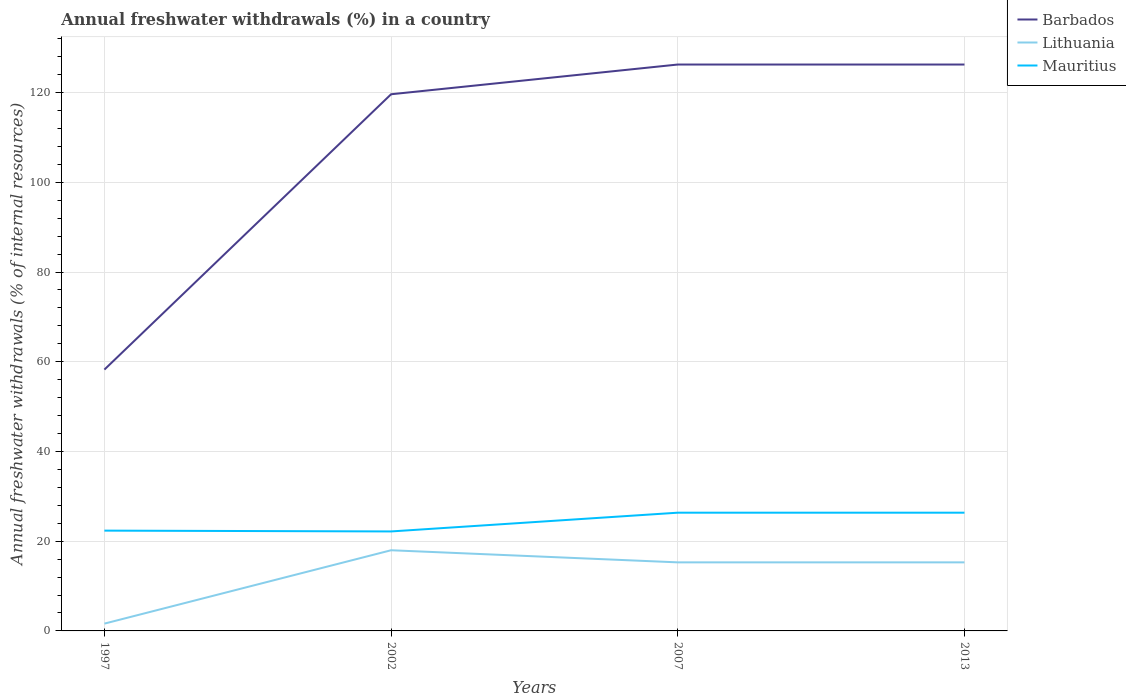How many different coloured lines are there?
Keep it short and to the point. 3. Is the number of lines equal to the number of legend labels?
Your response must be concise. Yes. Across all years, what is the maximum percentage of annual freshwater withdrawals in Lithuania?
Offer a very short reply. 1.63. What is the total percentage of annual freshwater withdrawals in Lithuania in the graph?
Your response must be concise. -13.66. What is the difference between the highest and the second highest percentage of annual freshwater withdrawals in Mauritius?
Your answer should be very brief. 4.18. Are the values on the major ticks of Y-axis written in scientific E-notation?
Your response must be concise. No. Does the graph contain any zero values?
Give a very brief answer. No. Does the graph contain grids?
Your response must be concise. Yes. How are the legend labels stacked?
Your response must be concise. Vertical. What is the title of the graph?
Your response must be concise. Annual freshwater withdrawals (%) in a country. Does "Qatar" appear as one of the legend labels in the graph?
Your response must be concise. No. What is the label or title of the Y-axis?
Ensure brevity in your answer.  Annual freshwater withdrawals (% of internal resources). What is the Annual freshwater withdrawals (% of internal resources) of Barbados in 1997?
Your response must be concise. 58.25. What is the Annual freshwater withdrawals (% of internal resources) of Lithuania in 1997?
Provide a succinct answer. 1.63. What is the Annual freshwater withdrawals (% of internal resources) of Mauritius in 1997?
Your answer should be compact. 22.36. What is the Annual freshwater withdrawals (% of internal resources) in Barbados in 2002?
Offer a very short reply. 119.62. What is the Annual freshwater withdrawals (% of internal resources) in Lithuania in 2002?
Ensure brevity in your answer.  17.98. What is the Annual freshwater withdrawals (% of internal resources) of Mauritius in 2002?
Offer a very short reply. 22.17. What is the Annual freshwater withdrawals (% of internal resources) of Barbados in 2007?
Ensure brevity in your answer.  126.25. What is the Annual freshwater withdrawals (% of internal resources) of Lithuania in 2007?
Offer a very short reply. 15.28. What is the Annual freshwater withdrawals (% of internal resources) in Mauritius in 2007?
Your answer should be very brief. 26.35. What is the Annual freshwater withdrawals (% of internal resources) of Barbados in 2013?
Your response must be concise. 126.25. What is the Annual freshwater withdrawals (% of internal resources) in Lithuania in 2013?
Keep it short and to the point. 15.28. What is the Annual freshwater withdrawals (% of internal resources) in Mauritius in 2013?
Offer a terse response. 26.35. Across all years, what is the maximum Annual freshwater withdrawals (% of internal resources) in Barbados?
Give a very brief answer. 126.25. Across all years, what is the maximum Annual freshwater withdrawals (% of internal resources) in Lithuania?
Provide a short and direct response. 17.98. Across all years, what is the maximum Annual freshwater withdrawals (% of internal resources) of Mauritius?
Your answer should be very brief. 26.35. Across all years, what is the minimum Annual freshwater withdrawals (% of internal resources) of Barbados?
Provide a short and direct response. 58.25. Across all years, what is the minimum Annual freshwater withdrawals (% of internal resources) in Lithuania?
Your answer should be very brief. 1.63. Across all years, what is the minimum Annual freshwater withdrawals (% of internal resources) of Mauritius?
Provide a succinct answer. 22.17. What is the total Annual freshwater withdrawals (% of internal resources) of Barbados in the graph?
Provide a succinct answer. 430.38. What is the total Annual freshwater withdrawals (% of internal resources) of Lithuania in the graph?
Ensure brevity in your answer.  50.17. What is the total Annual freshwater withdrawals (% of internal resources) in Mauritius in the graph?
Offer a very short reply. 97.24. What is the difference between the Annual freshwater withdrawals (% of internal resources) of Barbados in 1997 and that in 2002?
Give a very brief answer. -61.38. What is the difference between the Annual freshwater withdrawals (% of internal resources) of Lithuania in 1997 and that in 2002?
Offer a very short reply. -16.36. What is the difference between the Annual freshwater withdrawals (% of internal resources) of Mauritius in 1997 and that in 2002?
Provide a short and direct response. 0.18. What is the difference between the Annual freshwater withdrawals (% of internal resources) in Barbados in 1997 and that in 2007?
Make the answer very short. -68. What is the difference between the Annual freshwater withdrawals (% of internal resources) of Lithuania in 1997 and that in 2007?
Your response must be concise. -13.66. What is the difference between the Annual freshwater withdrawals (% of internal resources) in Mauritius in 1997 and that in 2007?
Provide a succinct answer. -4. What is the difference between the Annual freshwater withdrawals (% of internal resources) of Barbados in 1997 and that in 2013?
Your answer should be compact. -68. What is the difference between the Annual freshwater withdrawals (% of internal resources) in Lithuania in 1997 and that in 2013?
Make the answer very short. -13.66. What is the difference between the Annual freshwater withdrawals (% of internal resources) of Mauritius in 1997 and that in 2013?
Your answer should be very brief. -4. What is the difference between the Annual freshwater withdrawals (% of internal resources) in Barbados in 2002 and that in 2007?
Provide a succinct answer. -6.62. What is the difference between the Annual freshwater withdrawals (% of internal resources) of Lithuania in 2002 and that in 2007?
Give a very brief answer. 2.7. What is the difference between the Annual freshwater withdrawals (% of internal resources) in Mauritius in 2002 and that in 2007?
Provide a succinct answer. -4.18. What is the difference between the Annual freshwater withdrawals (% of internal resources) of Barbados in 2002 and that in 2013?
Offer a very short reply. -6.62. What is the difference between the Annual freshwater withdrawals (% of internal resources) of Lithuania in 2002 and that in 2013?
Provide a short and direct response. 2.7. What is the difference between the Annual freshwater withdrawals (% of internal resources) of Mauritius in 2002 and that in 2013?
Keep it short and to the point. -4.18. What is the difference between the Annual freshwater withdrawals (% of internal resources) in Barbados in 1997 and the Annual freshwater withdrawals (% of internal resources) in Lithuania in 2002?
Keep it short and to the point. 40.27. What is the difference between the Annual freshwater withdrawals (% of internal resources) of Barbados in 1997 and the Annual freshwater withdrawals (% of internal resources) of Mauritius in 2002?
Your answer should be compact. 36.08. What is the difference between the Annual freshwater withdrawals (% of internal resources) of Lithuania in 1997 and the Annual freshwater withdrawals (% of internal resources) of Mauritius in 2002?
Offer a very short reply. -20.55. What is the difference between the Annual freshwater withdrawals (% of internal resources) of Barbados in 1997 and the Annual freshwater withdrawals (% of internal resources) of Lithuania in 2007?
Offer a terse response. 42.97. What is the difference between the Annual freshwater withdrawals (% of internal resources) of Barbados in 1997 and the Annual freshwater withdrawals (% of internal resources) of Mauritius in 2007?
Make the answer very short. 31.9. What is the difference between the Annual freshwater withdrawals (% of internal resources) in Lithuania in 1997 and the Annual freshwater withdrawals (% of internal resources) in Mauritius in 2007?
Provide a short and direct response. -24.73. What is the difference between the Annual freshwater withdrawals (% of internal resources) in Barbados in 1997 and the Annual freshwater withdrawals (% of internal resources) in Lithuania in 2013?
Provide a succinct answer. 42.97. What is the difference between the Annual freshwater withdrawals (% of internal resources) of Barbados in 1997 and the Annual freshwater withdrawals (% of internal resources) of Mauritius in 2013?
Offer a very short reply. 31.9. What is the difference between the Annual freshwater withdrawals (% of internal resources) in Lithuania in 1997 and the Annual freshwater withdrawals (% of internal resources) in Mauritius in 2013?
Your answer should be compact. -24.73. What is the difference between the Annual freshwater withdrawals (% of internal resources) in Barbados in 2002 and the Annual freshwater withdrawals (% of internal resources) in Lithuania in 2007?
Offer a terse response. 104.34. What is the difference between the Annual freshwater withdrawals (% of internal resources) in Barbados in 2002 and the Annual freshwater withdrawals (% of internal resources) in Mauritius in 2007?
Offer a very short reply. 93.27. What is the difference between the Annual freshwater withdrawals (% of internal resources) in Lithuania in 2002 and the Annual freshwater withdrawals (% of internal resources) in Mauritius in 2007?
Provide a short and direct response. -8.37. What is the difference between the Annual freshwater withdrawals (% of internal resources) of Barbados in 2002 and the Annual freshwater withdrawals (% of internal resources) of Lithuania in 2013?
Offer a very short reply. 104.34. What is the difference between the Annual freshwater withdrawals (% of internal resources) in Barbados in 2002 and the Annual freshwater withdrawals (% of internal resources) in Mauritius in 2013?
Offer a terse response. 93.27. What is the difference between the Annual freshwater withdrawals (% of internal resources) in Lithuania in 2002 and the Annual freshwater withdrawals (% of internal resources) in Mauritius in 2013?
Your response must be concise. -8.37. What is the difference between the Annual freshwater withdrawals (% of internal resources) of Barbados in 2007 and the Annual freshwater withdrawals (% of internal resources) of Lithuania in 2013?
Ensure brevity in your answer.  110.97. What is the difference between the Annual freshwater withdrawals (% of internal resources) in Barbados in 2007 and the Annual freshwater withdrawals (% of internal resources) in Mauritius in 2013?
Make the answer very short. 99.9. What is the difference between the Annual freshwater withdrawals (% of internal resources) in Lithuania in 2007 and the Annual freshwater withdrawals (% of internal resources) in Mauritius in 2013?
Your answer should be compact. -11.07. What is the average Annual freshwater withdrawals (% of internal resources) of Barbados per year?
Offer a terse response. 107.59. What is the average Annual freshwater withdrawals (% of internal resources) in Lithuania per year?
Your answer should be very brief. 12.54. What is the average Annual freshwater withdrawals (% of internal resources) in Mauritius per year?
Make the answer very short. 24.31. In the year 1997, what is the difference between the Annual freshwater withdrawals (% of internal resources) of Barbados and Annual freshwater withdrawals (% of internal resources) of Lithuania?
Provide a short and direct response. 56.62. In the year 1997, what is the difference between the Annual freshwater withdrawals (% of internal resources) in Barbados and Annual freshwater withdrawals (% of internal resources) in Mauritius?
Give a very brief answer. 35.89. In the year 1997, what is the difference between the Annual freshwater withdrawals (% of internal resources) of Lithuania and Annual freshwater withdrawals (% of internal resources) of Mauritius?
Offer a terse response. -20.73. In the year 2002, what is the difference between the Annual freshwater withdrawals (% of internal resources) in Barbados and Annual freshwater withdrawals (% of internal resources) in Lithuania?
Your answer should be very brief. 101.64. In the year 2002, what is the difference between the Annual freshwater withdrawals (% of internal resources) in Barbados and Annual freshwater withdrawals (% of internal resources) in Mauritius?
Give a very brief answer. 97.45. In the year 2002, what is the difference between the Annual freshwater withdrawals (% of internal resources) of Lithuania and Annual freshwater withdrawals (% of internal resources) of Mauritius?
Your answer should be very brief. -4.19. In the year 2007, what is the difference between the Annual freshwater withdrawals (% of internal resources) in Barbados and Annual freshwater withdrawals (% of internal resources) in Lithuania?
Make the answer very short. 110.97. In the year 2007, what is the difference between the Annual freshwater withdrawals (% of internal resources) of Barbados and Annual freshwater withdrawals (% of internal resources) of Mauritius?
Provide a succinct answer. 99.9. In the year 2007, what is the difference between the Annual freshwater withdrawals (% of internal resources) of Lithuania and Annual freshwater withdrawals (% of internal resources) of Mauritius?
Provide a succinct answer. -11.07. In the year 2013, what is the difference between the Annual freshwater withdrawals (% of internal resources) in Barbados and Annual freshwater withdrawals (% of internal resources) in Lithuania?
Your response must be concise. 110.97. In the year 2013, what is the difference between the Annual freshwater withdrawals (% of internal resources) of Barbados and Annual freshwater withdrawals (% of internal resources) of Mauritius?
Provide a succinct answer. 99.9. In the year 2013, what is the difference between the Annual freshwater withdrawals (% of internal resources) of Lithuania and Annual freshwater withdrawals (% of internal resources) of Mauritius?
Your answer should be very brief. -11.07. What is the ratio of the Annual freshwater withdrawals (% of internal resources) of Barbados in 1997 to that in 2002?
Keep it short and to the point. 0.49. What is the ratio of the Annual freshwater withdrawals (% of internal resources) of Lithuania in 1997 to that in 2002?
Your response must be concise. 0.09. What is the ratio of the Annual freshwater withdrawals (% of internal resources) in Mauritius in 1997 to that in 2002?
Ensure brevity in your answer.  1.01. What is the ratio of the Annual freshwater withdrawals (% of internal resources) in Barbados in 1997 to that in 2007?
Your answer should be very brief. 0.46. What is the ratio of the Annual freshwater withdrawals (% of internal resources) in Lithuania in 1997 to that in 2007?
Give a very brief answer. 0.11. What is the ratio of the Annual freshwater withdrawals (% of internal resources) of Mauritius in 1997 to that in 2007?
Offer a terse response. 0.85. What is the ratio of the Annual freshwater withdrawals (% of internal resources) of Barbados in 1997 to that in 2013?
Keep it short and to the point. 0.46. What is the ratio of the Annual freshwater withdrawals (% of internal resources) in Lithuania in 1997 to that in 2013?
Keep it short and to the point. 0.11. What is the ratio of the Annual freshwater withdrawals (% of internal resources) in Mauritius in 1997 to that in 2013?
Your response must be concise. 0.85. What is the ratio of the Annual freshwater withdrawals (% of internal resources) of Barbados in 2002 to that in 2007?
Make the answer very short. 0.95. What is the ratio of the Annual freshwater withdrawals (% of internal resources) of Lithuania in 2002 to that in 2007?
Offer a very short reply. 1.18. What is the ratio of the Annual freshwater withdrawals (% of internal resources) of Mauritius in 2002 to that in 2007?
Keep it short and to the point. 0.84. What is the ratio of the Annual freshwater withdrawals (% of internal resources) of Barbados in 2002 to that in 2013?
Ensure brevity in your answer.  0.95. What is the ratio of the Annual freshwater withdrawals (% of internal resources) of Lithuania in 2002 to that in 2013?
Your answer should be compact. 1.18. What is the ratio of the Annual freshwater withdrawals (% of internal resources) of Mauritius in 2002 to that in 2013?
Your answer should be compact. 0.84. What is the ratio of the Annual freshwater withdrawals (% of internal resources) of Barbados in 2007 to that in 2013?
Your answer should be very brief. 1. What is the ratio of the Annual freshwater withdrawals (% of internal resources) of Mauritius in 2007 to that in 2013?
Provide a short and direct response. 1. What is the difference between the highest and the second highest Annual freshwater withdrawals (% of internal resources) of Lithuania?
Provide a short and direct response. 2.7. What is the difference between the highest and the second highest Annual freshwater withdrawals (% of internal resources) of Mauritius?
Keep it short and to the point. 0. What is the difference between the highest and the lowest Annual freshwater withdrawals (% of internal resources) of Barbados?
Ensure brevity in your answer.  68. What is the difference between the highest and the lowest Annual freshwater withdrawals (% of internal resources) in Lithuania?
Ensure brevity in your answer.  16.36. What is the difference between the highest and the lowest Annual freshwater withdrawals (% of internal resources) in Mauritius?
Provide a succinct answer. 4.18. 